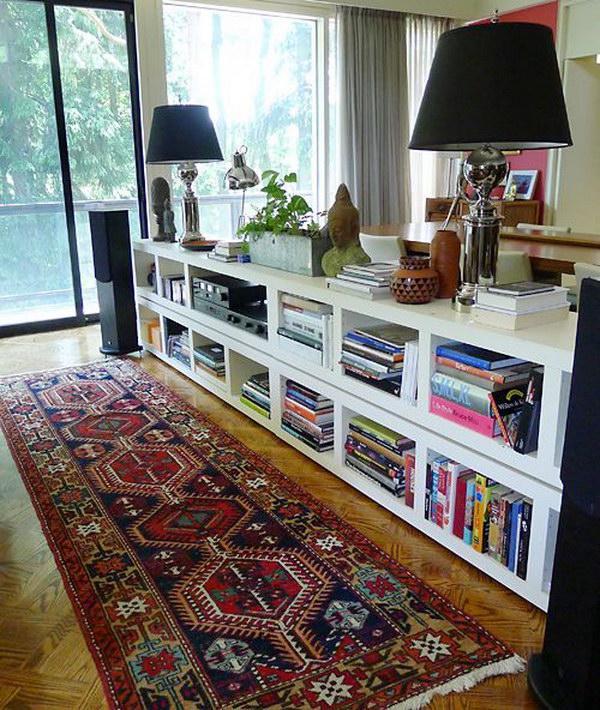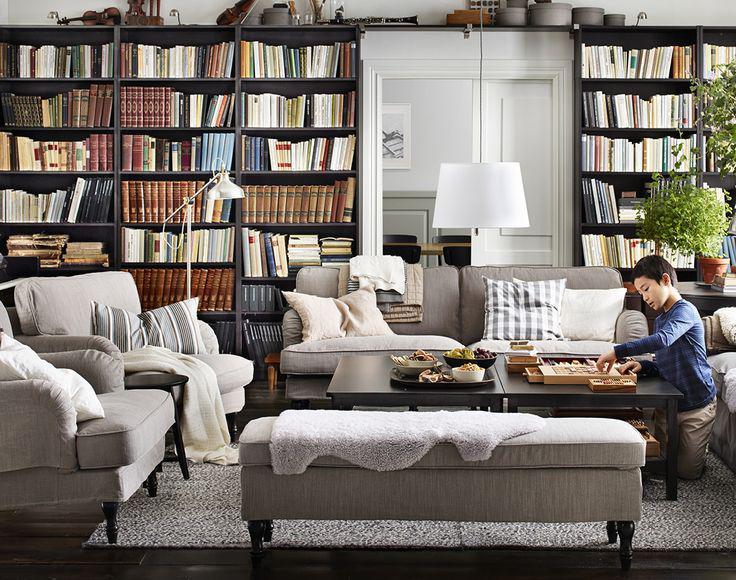The first image is the image on the left, the second image is the image on the right. Given the left and right images, does the statement "There are two lamps with pale shades mounted on the wall behind the couch in one of the images." hold true? Answer yes or no. No. The first image is the image on the left, the second image is the image on the right. For the images displayed, is the sentence "in the left image there is a tall window near a book case" factually correct? Answer yes or no. Yes. 